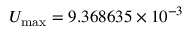<formula> <loc_0><loc_0><loc_500><loc_500>U _ { \max } = 9 . 3 6 8 6 3 5 \times 1 0 ^ { - 3 }</formula> 